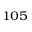Convert formula to latex. <formula><loc_0><loc_0><loc_500><loc_500>^ { 1 0 5 }</formula> 